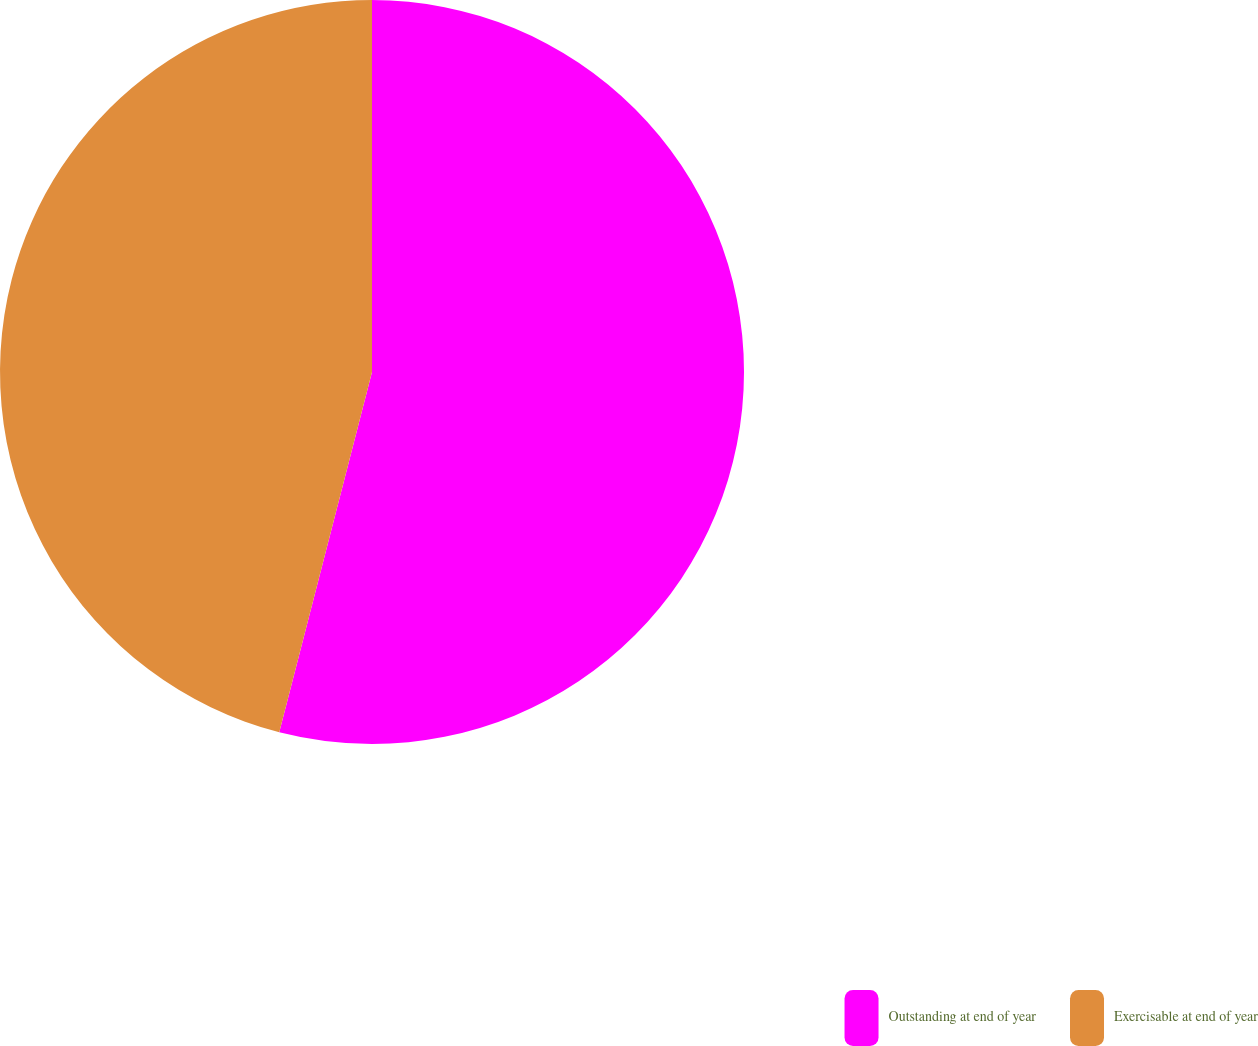Convert chart. <chart><loc_0><loc_0><loc_500><loc_500><pie_chart><fcel>Outstanding at end of year<fcel>Exercisable at end of year<nl><fcel>54.01%<fcel>45.99%<nl></chart> 